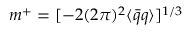<formula> <loc_0><loc_0><loc_500><loc_500>m ^ { + } = [ - 2 ( 2 \pi ) ^ { 2 } \langle \bar { q } q \rangle ] ^ { 1 / 3 }</formula> 